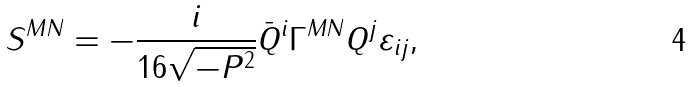<formula> <loc_0><loc_0><loc_500><loc_500>S ^ { M N } = - \frac { i } { 1 6 \sqrt { - P ^ { 2 } } } \bar { Q } ^ { i } \Gamma ^ { M N } { Q } ^ { j } \varepsilon _ { i j } ,</formula> 